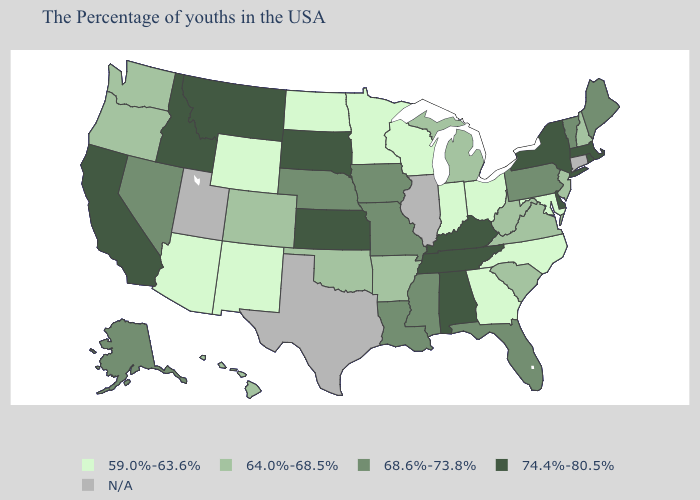Among the states that border West Virginia , which have the lowest value?
Write a very short answer. Maryland, Ohio. Name the states that have a value in the range 74.4%-80.5%?
Give a very brief answer. Massachusetts, Rhode Island, New York, Delaware, Kentucky, Alabama, Tennessee, Kansas, South Dakota, Montana, Idaho, California. Does South Dakota have the highest value in the MidWest?
Answer briefly. Yes. Which states have the highest value in the USA?
Answer briefly. Massachusetts, Rhode Island, New York, Delaware, Kentucky, Alabama, Tennessee, Kansas, South Dakota, Montana, Idaho, California. What is the highest value in the Northeast ?
Answer briefly. 74.4%-80.5%. Among the states that border Idaho , which have the lowest value?
Be succinct. Wyoming. Name the states that have a value in the range 59.0%-63.6%?
Answer briefly. Maryland, North Carolina, Ohio, Georgia, Indiana, Wisconsin, Minnesota, North Dakota, Wyoming, New Mexico, Arizona. What is the value of Iowa?
Quick response, please. 68.6%-73.8%. How many symbols are there in the legend?
Short answer required. 5. What is the highest value in the MidWest ?
Concise answer only. 74.4%-80.5%. What is the value of Alaska?
Be succinct. 68.6%-73.8%. Name the states that have a value in the range 59.0%-63.6%?
Give a very brief answer. Maryland, North Carolina, Ohio, Georgia, Indiana, Wisconsin, Minnesota, North Dakota, Wyoming, New Mexico, Arizona. Which states have the lowest value in the MidWest?
Short answer required. Ohio, Indiana, Wisconsin, Minnesota, North Dakota. 